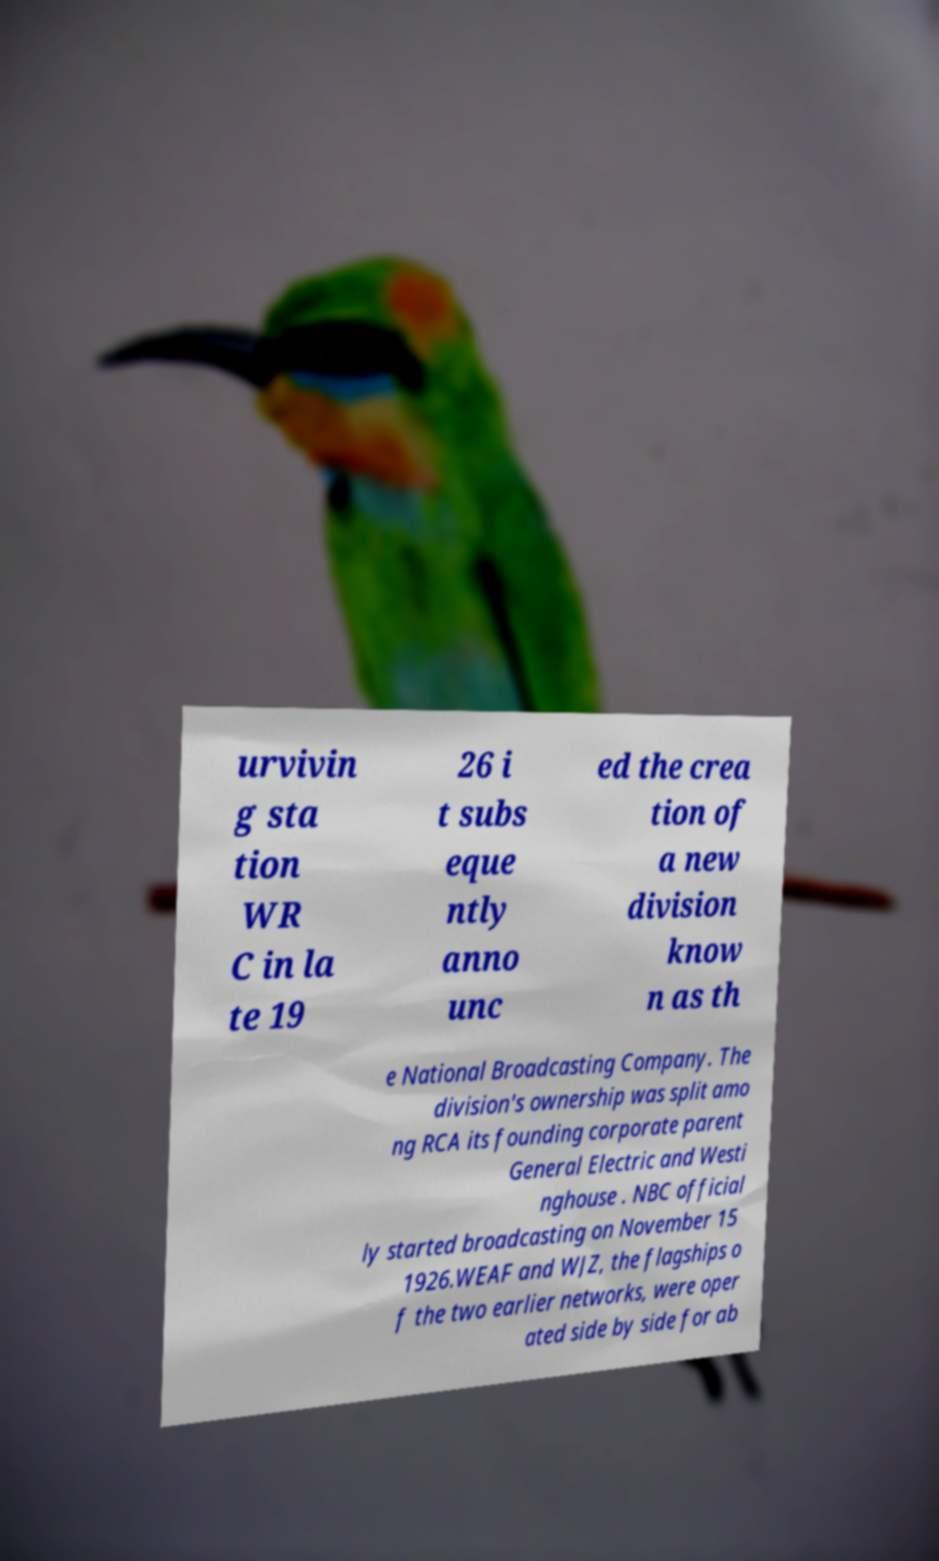I need the written content from this picture converted into text. Can you do that? urvivin g sta tion WR C in la te 19 26 i t subs eque ntly anno unc ed the crea tion of a new division know n as th e National Broadcasting Company. The division's ownership was split amo ng RCA its founding corporate parent General Electric and Westi nghouse . NBC official ly started broadcasting on November 15 1926.WEAF and WJZ, the flagships o f the two earlier networks, were oper ated side by side for ab 